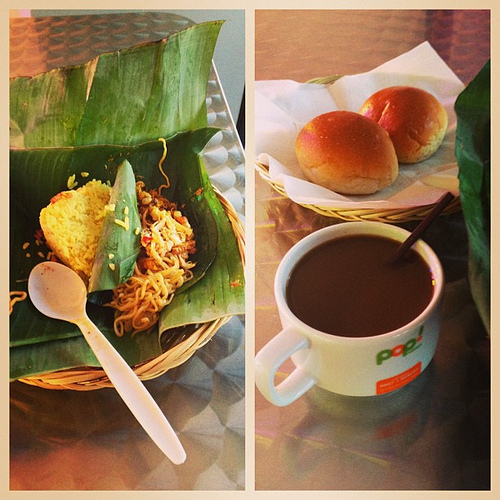What drink is to the right of the utensil made of plastic? To the right of the plastic spoon lies your trusty companion, a steaming mug of coffee, exuding its inviting aroma. 